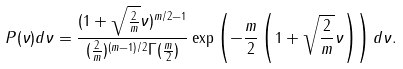Convert formula to latex. <formula><loc_0><loc_0><loc_500><loc_500>P ( \nu ) d \nu = \frac { ( 1 + \sqrt { \frac { 2 } { m } } \nu ) ^ { m / 2 - 1 } } { ( \frac { 2 } { m } ) ^ { ( m - 1 ) / 2 } \Gamma ( \frac { m } { 2 } ) } \exp \left ( - \frac { m } { 2 } \left ( 1 + \sqrt { \frac { 2 } { m } } \nu \right ) \right ) d \nu .</formula> 